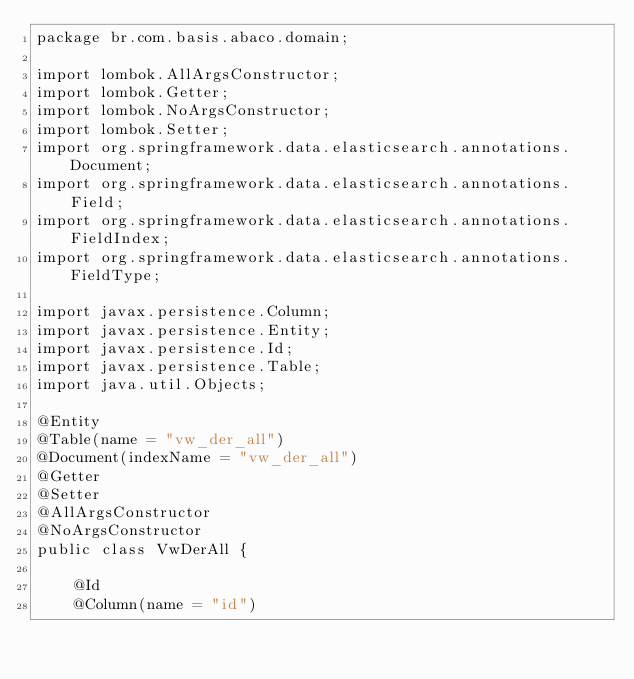Convert code to text. <code><loc_0><loc_0><loc_500><loc_500><_Java_>package br.com.basis.abaco.domain;

import lombok.AllArgsConstructor;
import lombok.Getter;
import lombok.NoArgsConstructor;
import lombok.Setter;
import org.springframework.data.elasticsearch.annotations.Document;
import org.springframework.data.elasticsearch.annotations.Field;
import org.springframework.data.elasticsearch.annotations.FieldIndex;
import org.springframework.data.elasticsearch.annotations.FieldType;

import javax.persistence.Column;
import javax.persistence.Entity;
import javax.persistence.Id;
import javax.persistence.Table;
import java.util.Objects;

@Entity
@Table(name = "vw_der_all")
@Document(indexName = "vw_der_all")
@Getter
@Setter
@AllArgsConstructor
@NoArgsConstructor
public class VwDerAll {

    @Id
    @Column(name = "id")</code> 